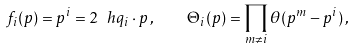Convert formula to latex. <formula><loc_0><loc_0><loc_500><loc_500>f _ { i } ( p ) = p ^ { i } = 2 \ h q _ { i } \cdot p \, , \quad \Theta _ { i } ( p ) = \prod _ { m \neq i } \theta ( p ^ { m } - p ^ { i } ) \, ,</formula> 